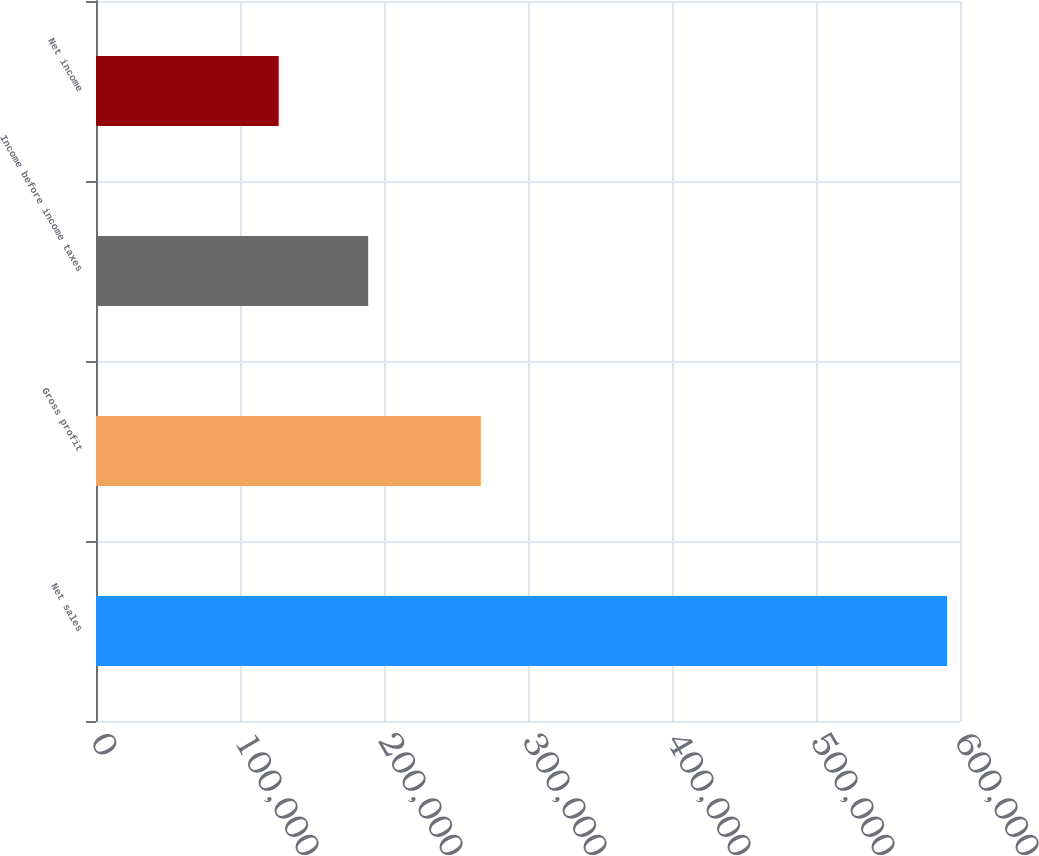Convert chart to OTSL. <chart><loc_0><loc_0><loc_500><loc_500><bar_chart><fcel>Net sales<fcel>Gross profit<fcel>Income before income taxes<fcel>Net income<nl><fcel>590980<fcel>267241<fcel>189016<fcel>126872<nl></chart> 